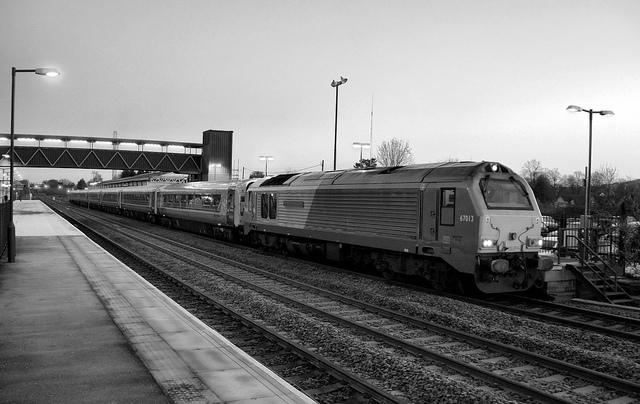Is the train moving?
Quick response, please. No. What number is on the train?
Write a very short answer. 67013. Is this the rear of the train?
Short answer required. No. Is this a passenger train?
Concise answer only. Yes. Are the street lights on?
Give a very brief answer. Yes. What color is the sky?
Be succinct. Gray. How many engine cars are there before the light gray container car?
Short answer required. 1. Is this a train?
Be succinct. Yes. How many light poles do you see?
Write a very short answer. 5. How many tracks are here?
Be succinct. 2. Is the cars headlights on?
Give a very brief answer. Yes. Are there power lines above the train?
Write a very short answer. No. 